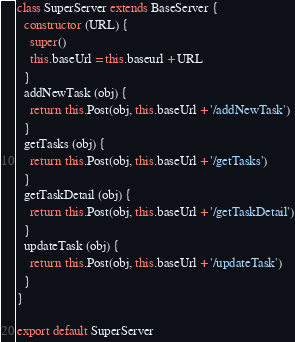Convert code to text. <code><loc_0><loc_0><loc_500><loc_500><_JavaScript_>class SuperServer extends BaseServer {
  constructor (URL) {
    super()
    this.baseUrl = this.baseurl + URL
  }
  addNewTask (obj) {
    return this.Post(obj, this.baseUrl + '/addNewTask')
  }
  getTasks (obj) {
    return this.Post(obj, this.baseUrl + '/getTasks')
  }
  getTaskDetail (obj) {
    return this.Post(obj, this.baseUrl + '/getTaskDetail')
  }
  updateTask (obj) {
    return this.Post(obj, this.baseUrl + '/updateTask')
  }
}

export default SuperServer
</code> 